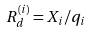<formula> <loc_0><loc_0><loc_500><loc_500>R _ { d } ^ { ( i ) } = X _ { i } / q _ { i }</formula> 